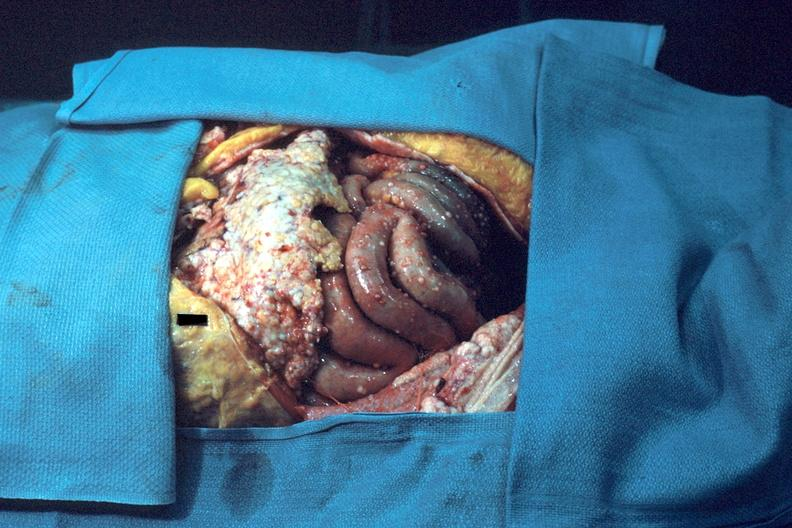s carcinomatosis endometrium primary present?
Answer the question using a single word or phrase. Yes 